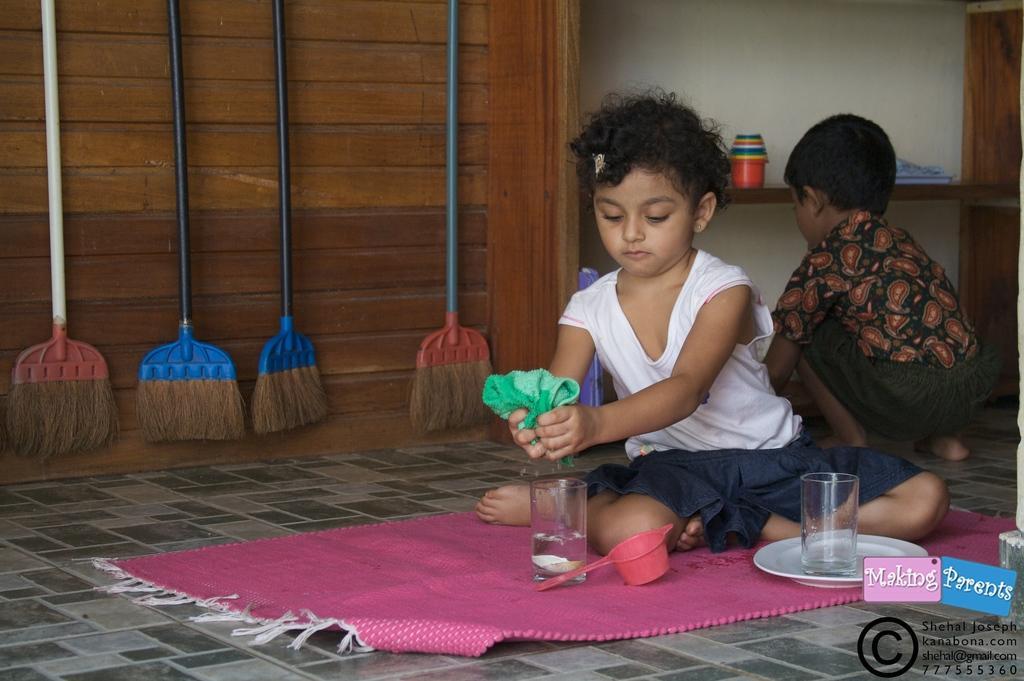Could you give a brief overview of what you see in this image? In the picture I can see a girl is holding a cloth in hands. I can also see a boy is crouching on the floor. In the background I can see broomsticks, a mat, a glass on a plate and some other objects. On the bottom right side of the image I can see a watermark. 